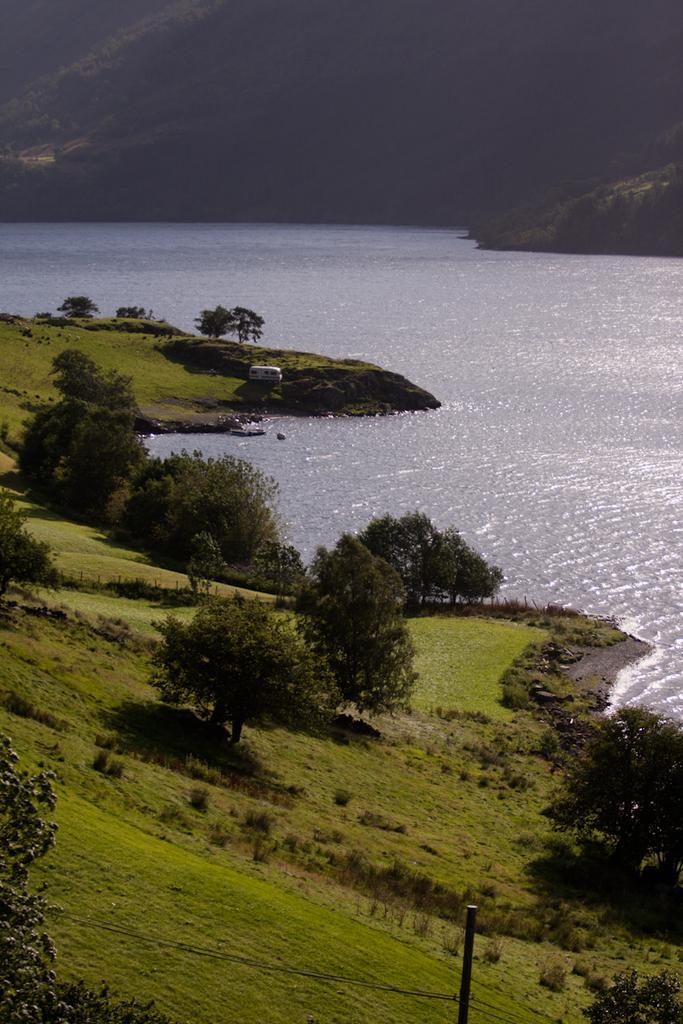Describe this image in one or two sentences. In the picture I can see the natural scenery of green grass and trees. I can see the ocean on the right side. There is a vehicle on the side of the ocean. In the background, I can see the hills. I can see a pole on the bottom right side of the picture. 